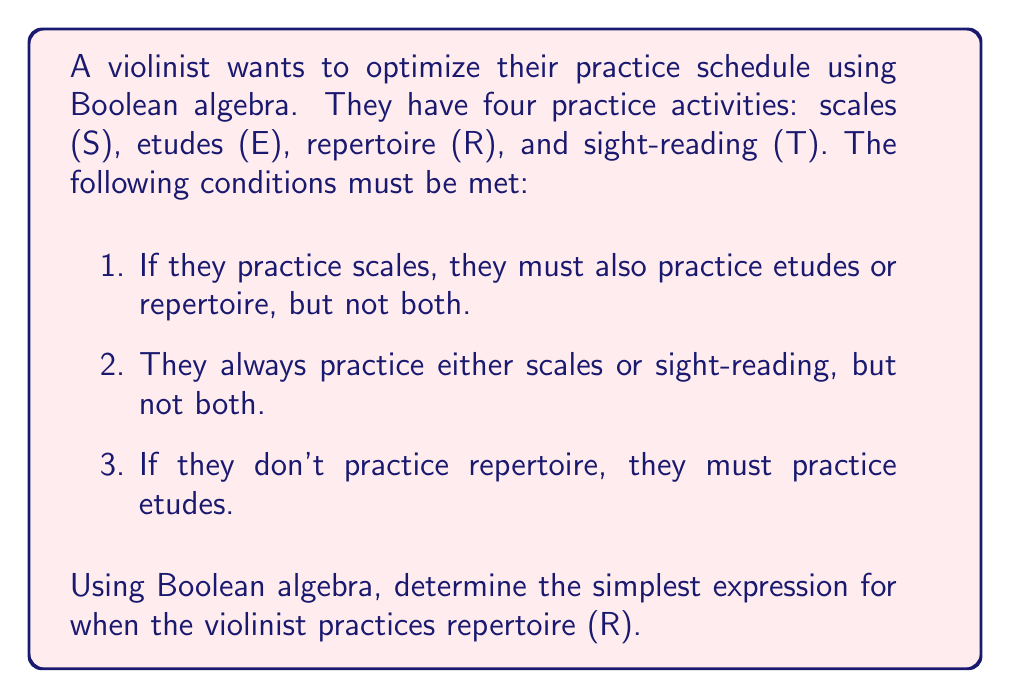What is the answer to this math problem? Let's approach this step-by-step using Boolean algebra:

1. First, let's express the given conditions as Boolean equations:
   a. $S \rightarrow (E \oplus R)$, where $\oplus$ is XOR (exclusive or)
   b. $S \oplus T$
   c. $\overline{R} \rightarrow E$, which is equivalent to $R \vee E$

2. We want to find an expression for R. Let's start with condition (c):
   $R \vee E$

3. Now, let's incorporate condition (a). We know that if S is true, either E or R must be true, but not both. This can be expressed as:
   $S \rightarrow (E \oplus R)$
   $\equiv \overline{S} \vee (E \oplus R)$

4. Combining this with our expression from step 2:
   $R \equiv (R \vee E) \wedge [\overline{S} \vee (E \oplus R)]$

5. Expanding this expression:
   $R \equiv (R \vee E) \wedge (\overline{S} \vee E \vee R) \wedge (\overline{S} \vee \overline{E} \vee \overline{R})$

6. Simplifying:
   $R \equiv R \wedge (\overline{S} \vee \overline{E})$
   $\equiv R \wedge \overline{S} \vee R \wedge \overline{E}$

7. From condition (b), we know that $S \oplus T \equiv 1$, which means $T \equiv \overline{S}$

8. Substituting $T$ for $\overline{S}$ in our expression:
   $R \equiv R \wedge T \vee R \wedge \overline{E}$

This is the simplest form we can achieve given the conditions.
Answer: $R \equiv R \wedge T \vee R \wedge \overline{E}$ 